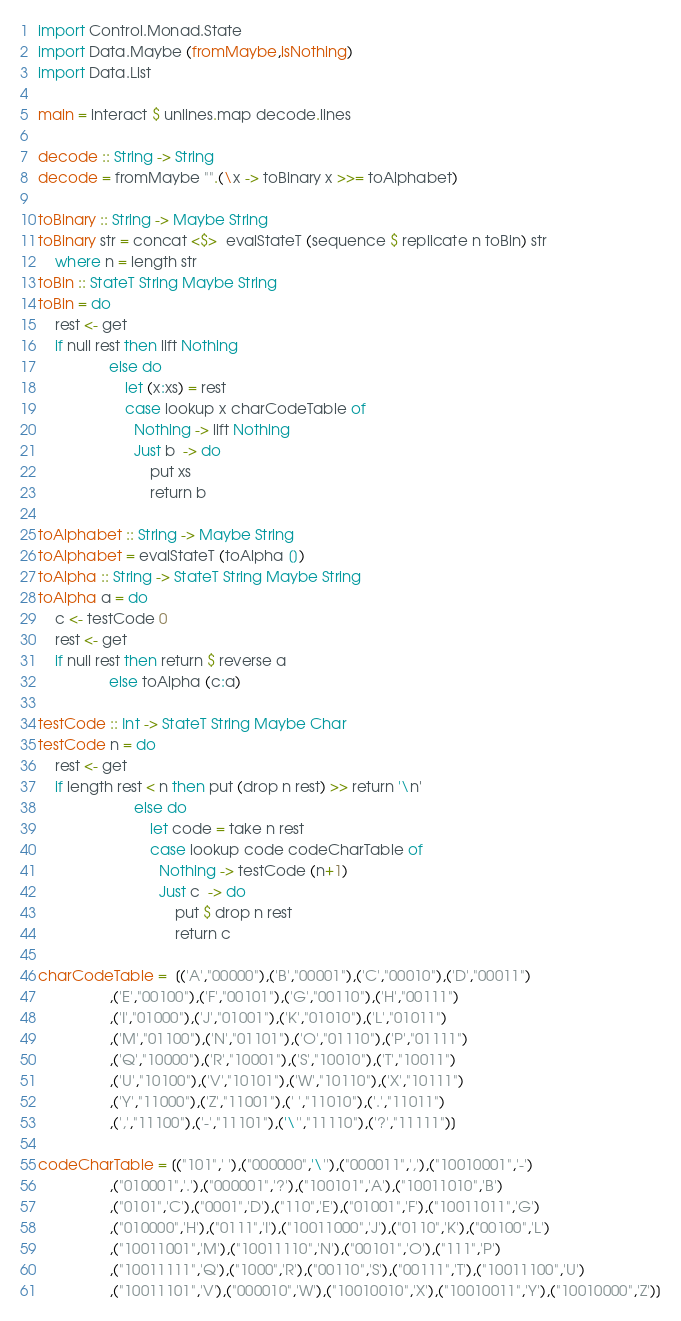Convert code to text. <code><loc_0><loc_0><loc_500><loc_500><_Haskell_>import Control.Monad.State
import Data.Maybe (fromMaybe,isNothing)
import Data.List

main = interact $ unlines.map decode.lines

decode :: String -> String
decode = fromMaybe "".(\x -> toBinary x >>= toAlphabet)

toBinary :: String -> Maybe String
toBinary str = concat <$>  evalStateT (sequence $ replicate n toBin) str
    where n = length str
toBin :: StateT String Maybe String
toBin = do
    rest <- get
    if null rest then lift Nothing
                 else do
                     let (x:xs) = rest
                     case lookup x charCodeTable of
                       Nothing -> lift Nothing
                       Just b  -> do
                           put xs
                           return b

toAlphabet :: String -> Maybe String
toAlphabet = evalStateT (toAlpha [])
toAlpha :: String -> StateT String Maybe String
toAlpha a = do
    c <- testCode 0
    rest <- get
    if null rest then return $ reverse a
                 else toAlpha (c:a)

testCode :: Int -> StateT String Maybe Char
testCode n = do
    rest <- get
    if length rest < n then put (drop n rest) >> return '\n'
                       else do
                           let code = take n rest
                           case lookup code codeCharTable of
                             Nothing -> testCode (n+1)
                             Just c  -> do
                                 put $ drop n rest
                                 return c

charCodeTable =  [('A',"00000"),('B',"00001"),('C',"00010"),('D',"00011")
                 ,('E',"00100"),('F',"00101"),('G',"00110"),('H',"00111")
                 ,('I',"01000"),('J',"01001"),('K',"01010"),('L',"01011")
                 ,('M',"01100"),('N',"01101"),('O',"01110"),('P',"01111")
                 ,('Q',"10000"),('R',"10001"),('S',"10010"),('T',"10011")
                 ,('U',"10100"),('V',"10101"),('W',"10110"),('X',"10111")
                 ,('Y',"11000"),('Z',"11001"),(' ',"11010"),('.',"11011")
                 ,(',',"11100"),('-',"11101"),('\'',"11110"),('?',"11111")]

codeCharTable = [("101",' '),("000000",'\''),("000011",','),("10010001",'-')
                 ,("010001",'.'),("000001",'?'),("100101",'A'),("10011010",'B')
                 ,("0101",'C'),("0001",'D'),("110",'E'),("01001",'F'),("10011011",'G')
                 ,("010000",'H'),("0111",'I'),("10011000",'J'),("0110",'K'),("00100",'L')
                 ,("10011001",'M'),("10011110",'N'),("00101",'O'),("111",'P')
                 ,("10011111",'Q'),("1000",'R'),("00110",'S'),("00111",'T'),("10011100",'U')
                 ,("10011101",'V'),("000010",'W'),("10010010",'X'),("10010011",'Y'),("10010000",'Z')]</code> 